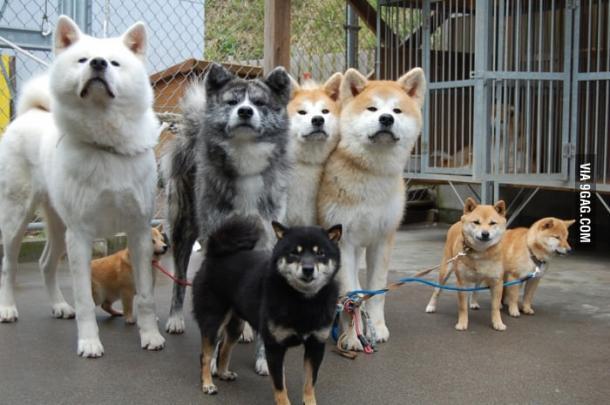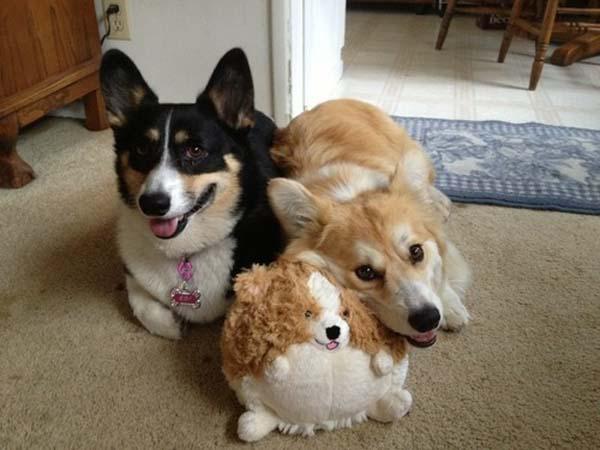The first image is the image on the left, the second image is the image on the right. Examine the images to the left and right. Is the description "There are at most four dogs." accurate? Answer yes or no. No. 